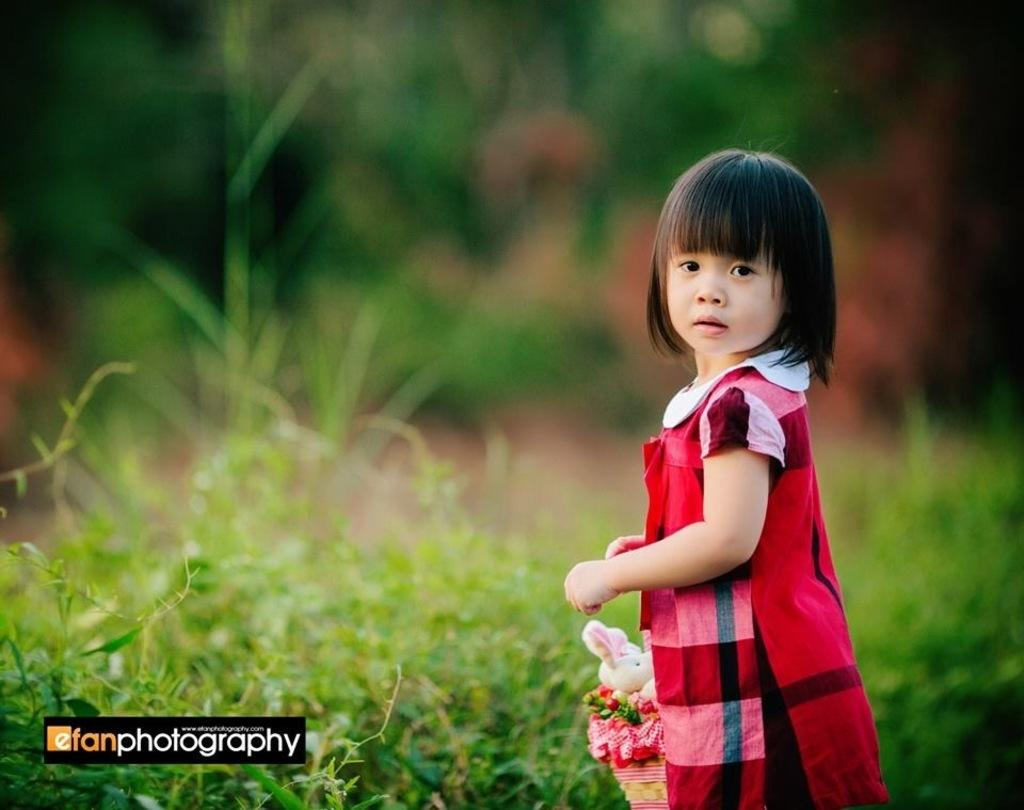<image>
Provide a brief description of the given image. the picture of the little girl is provided by efanphotography 